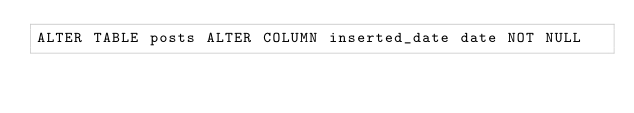<code> <loc_0><loc_0><loc_500><loc_500><_SQL_>ALTER TABLE posts ALTER COLUMN inserted_date date NOT NULL</code> 